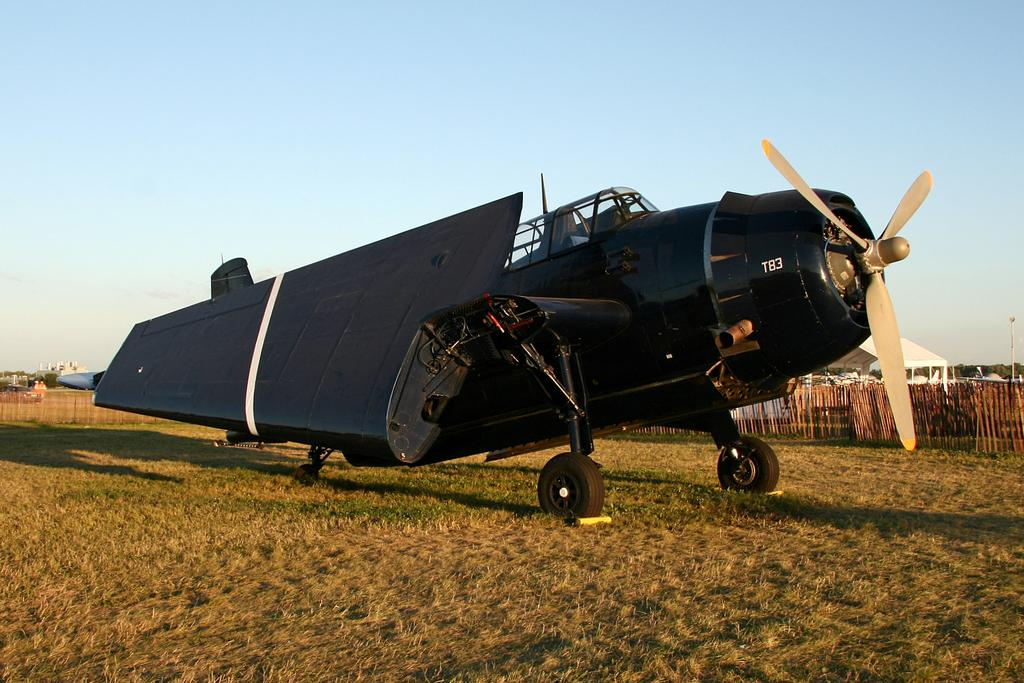<image>
Present a compact description of the photo's key features. A black T83 plane on a field with its wings folded in. 